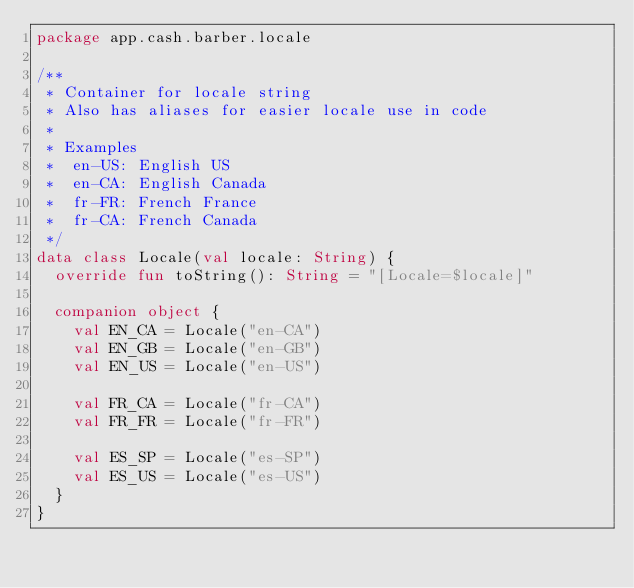<code> <loc_0><loc_0><loc_500><loc_500><_Kotlin_>package app.cash.barber.locale

/**
 * Container for locale string
 * Also has aliases for easier locale use in code
 *
 * Examples
 *  en-US: English US
 *  en-CA: English Canada
 *  fr-FR: French France
 *  fr-CA: French Canada
 */
data class Locale(val locale: String) {
  override fun toString(): String = "[Locale=$locale]"

  companion object {
    val EN_CA = Locale("en-CA")
    val EN_GB = Locale("en-GB")
    val EN_US = Locale("en-US")

    val FR_CA = Locale("fr-CA")
    val FR_FR = Locale("fr-FR")

    val ES_SP = Locale("es-SP")
    val ES_US = Locale("es-US")
  }
}
</code> 